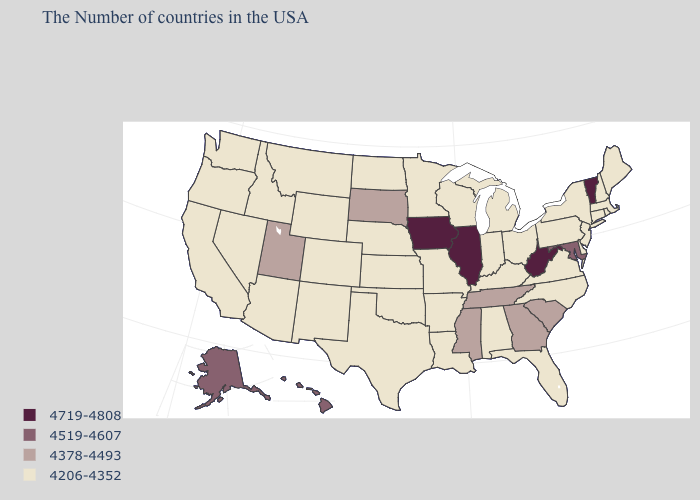Does the first symbol in the legend represent the smallest category?
Be succinct. No. Does North Dakota have the highest value in the MidWest?
Concise answer only. No. Name the states that have a value in the range 4378-4493?
Quick response, please. South Carolina, Georgia, Tennessee, Mississippi, South Dakota, Utah. Which states have the lowest value in the South?
Be succinct. Delaware, Virginia, North Carolina, Florida, Kentucky, Alabama, Louisiana, Arkansas, Oklahoma, Texas. What is the value of South Dakota?
Concise answer only. 4378-4493. What is the value of Kentucky?
Be succinct. 4206-4352. Which states hav the highest value in the West?
Be succinct. Alaska, Hawaii. Name the states that have a value in the range 4378-4493?
Be succinct. South Carolina, Georgia, Tennessee, Mississippi, South Dakota, Utah. Which states hav the highest value in the MidWest?
Short answer required. Illinois, Iowa. What is the value of Arizona?
Quick response, please. 4206-4352. Does Washington have the lowest value in the West?
Give a very brief answer. Yes. What is the value of North Dakota?
Be succinct. 4206-4352. Among the states that border Louisiana , which have the highest value?
Quick response, please. Mississippi. What is the value of Illinois?
Answer briefly. 4719-4808. Name the states that have a value in the range 4378-4493?
Answer briefly. South Carolina, Georgia, Tennessee, Mississippi, South Dakota, Utah. 